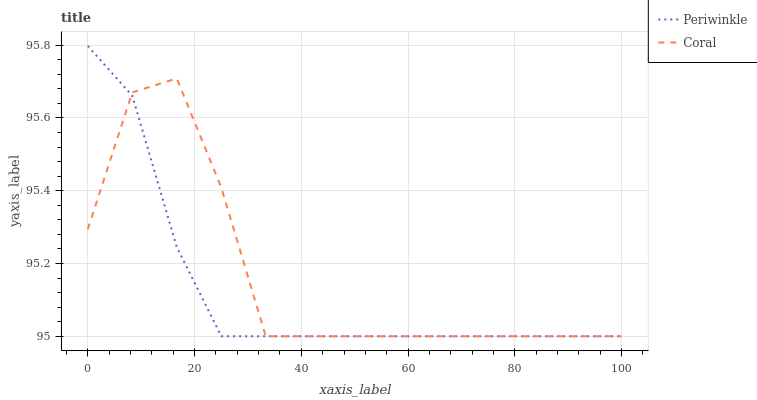Does Periwinkle have the minimum area under the curve?
Answer yes or no. Yes. Does Coral have the maximum area under the curve?
Answer yes or no. Yes. Does Periwinkle have the maximum area under the curve?
Answer yes or no. No. Is Periwinkle the smoothest?
Answer yes or no. Yes. Is Coral the roughest?
Answer yes or no. Yes. Is Periwinkle the roughest?
Answer yes or no. No. Does Coral have the lowest value?
Answer yes or no. Yes. Does Periwinkle have the highest value?
Answer yes or no. Yes. Does Coral intersect Periwinkle?
Answer yes or no. Yes. Is Coral less than Periwinkle?
Answer yes or no. No. Is Coral greater than Periwinkle?
Answer yes or no. No. 